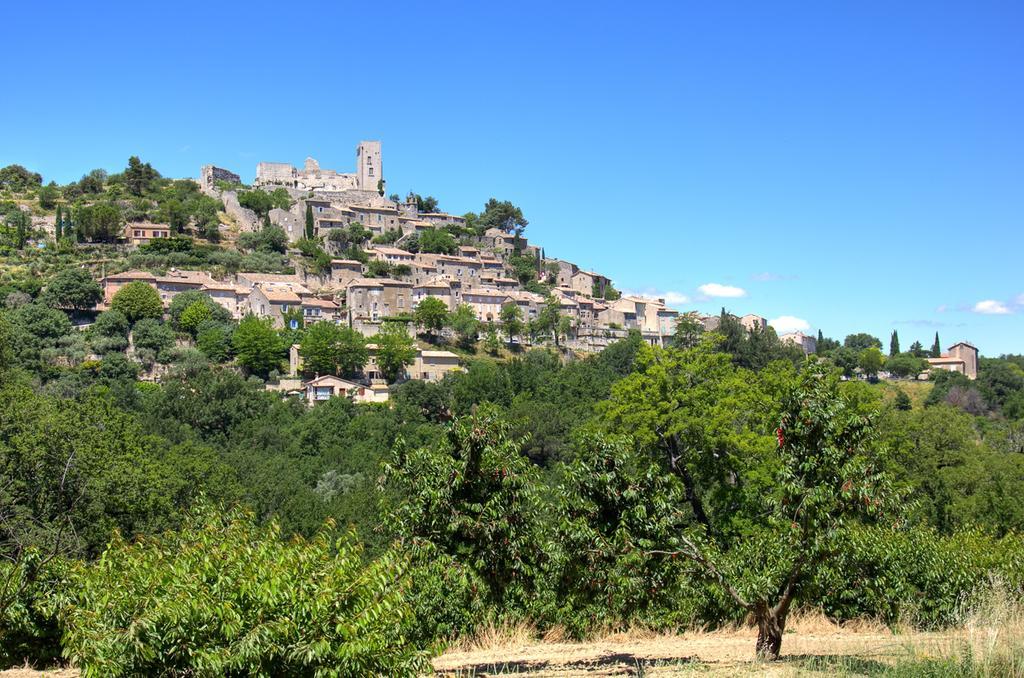How would you summarize this image in a sentence or two? There are trees and few buildings and the sky is blue in color. 